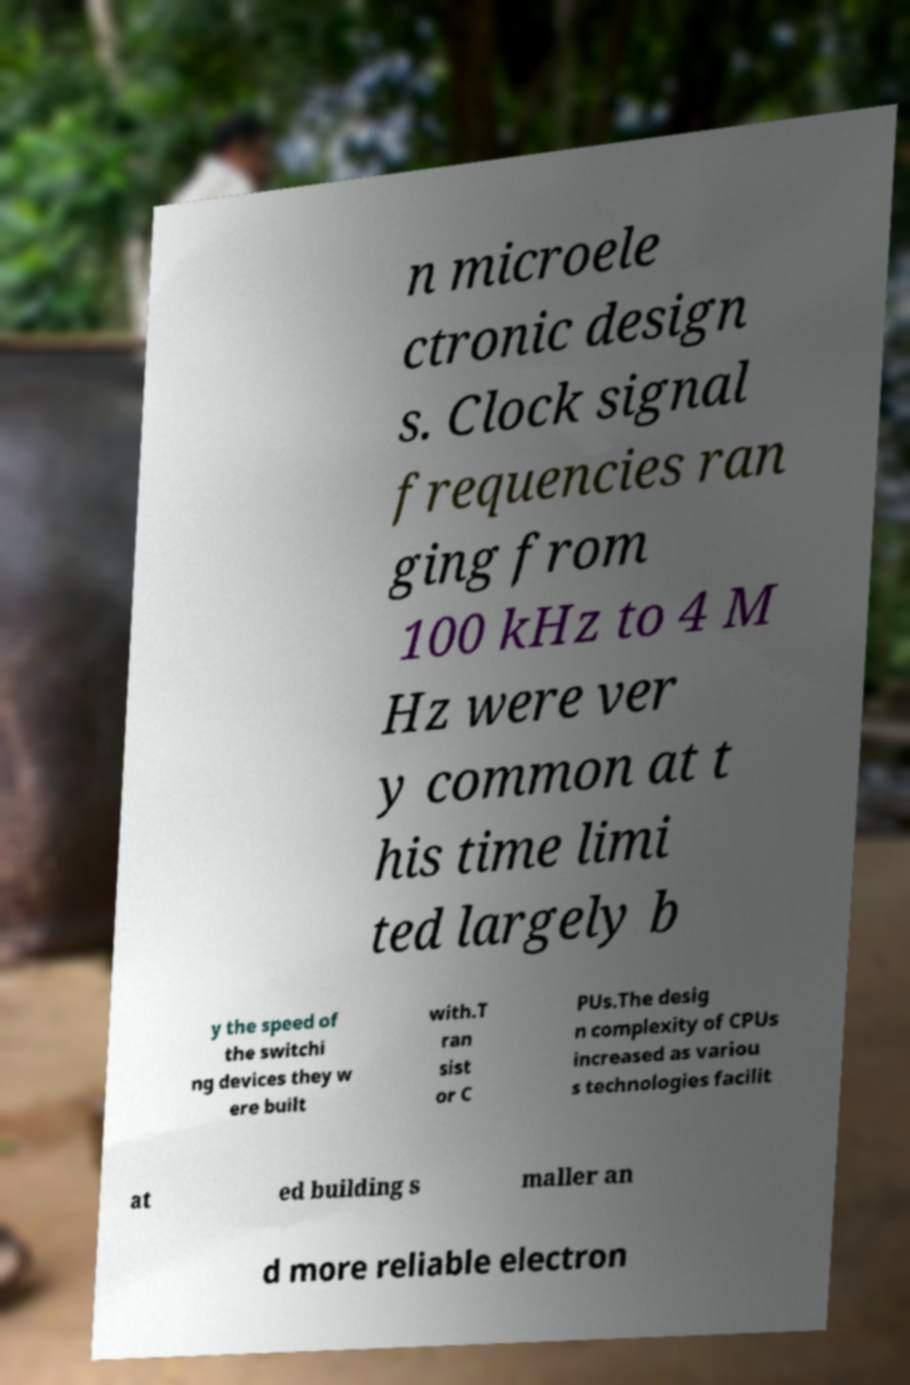Please identify and transcribe the text found in this image. n microele ctronic design s. Clock signal frequencies ran ging from 100 kHz to 4 M Hz were ver y common at t his time limi ted largely b y the speed of the switchi ng devices they w ere built with.T ran sist or C PUs.The desig n complexity of CPUs increased as variou s technologies facilit at ed building s maller an d more reliable electron 